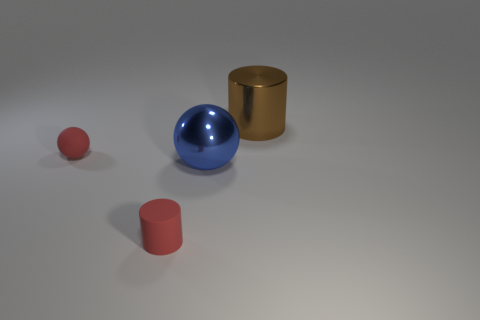Add 3 large metallic things. How many objects exist? 7 Subtract all gray cylinders. Subtract all brown spheres. How many cylinders are left? 2 Subtract all red shiny cubes. Subtract all big balls. How many objects are left? 3 Add 3 brown objects. How many brown objects are left? 4 Add 1 yellow metal cylinders. How many yellow metal cylinders exist? 1 Subtract 0 gray balls. How many objects are left? 4 